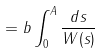Convert formula to latex. <formula><loc_0><loc_0><loc_500><loc_500>= b \int _ { 0 } ^ { A } \frac { d s } { W ( s ) }</formula> 